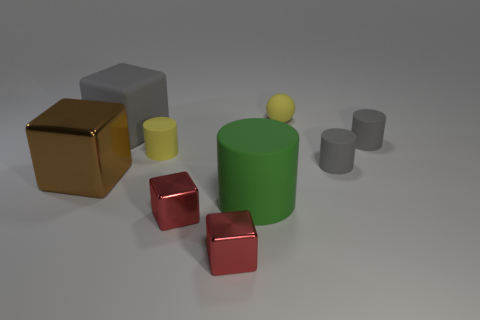Add 1 green rubber objects. How many objects exist? 10 Subtract all cylinders. How many objects are left? 5 Subtract all large matte blocks. Subtract all matte balls. How many objects are left? 7 Add 5 small cylinders. How many small cylinders are left? 8 Add 5 rubber blocks. How many rubber blocks exist? 6 Subtract 1 yellow cylinders. How many objects are left? 8 